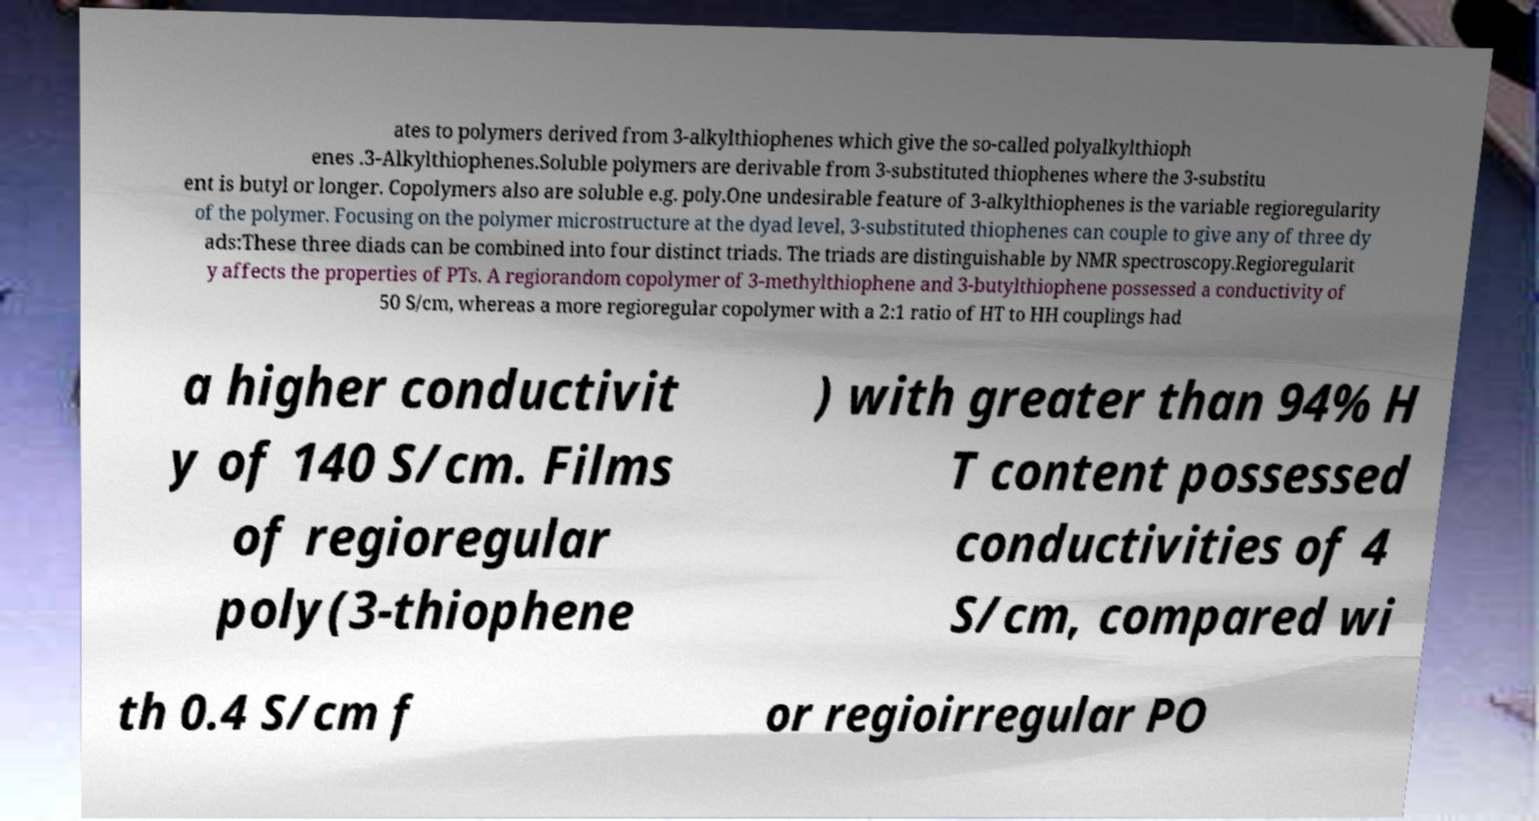What messages or text are displayed in this image? I need them in a readable, typed format. ates to polymers derived from 3-alkylthiophenes which give the so-called polyalkylthioph enes .3-Alkylthiophenes.Soluble polymers are derivable from 3-substituted thiophenes where the 3-substitu ent is butyl or longer. Copolymers also are soluble e.g. poly.One undesirable feature of 3-alkylthiophenes is the variable regioregularity of the polymer. Focusing on the polymer microstructure at the dyad level, 3-substituted thiophenes can couple to give any of three dy ads:These three diads can be combined into four distinct triads. The triads are distinguishable by NMR spectroscopy.Regioregularit y affects the properties of PTs. A regiorandom copolymer of 3-methylthiophene and 3-butylthiophene possessed a conductivity of 50 S/cm, whereas a more regioregular copolymer with a 2:1 ratio of HT to HH couplings had a higher conductivit y of 140 S/cm. Films of regioregular poly(3-thiophene ) with greater than 94% H T content possessed conductivities of 4 S/cm, compared wi th 0.4 S/cm f or regioirregular PO 